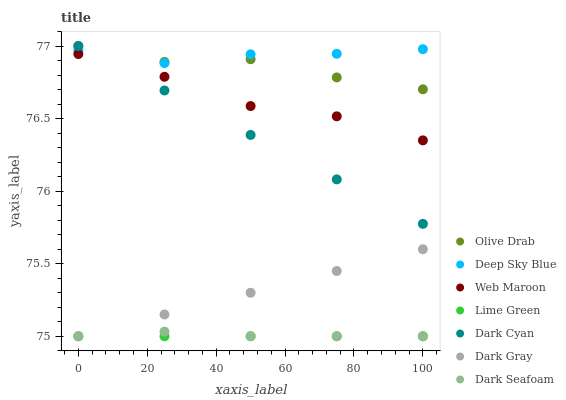Does Lime Green have the minimum area under the curve?
Answer yes or no. Yes. Does Deep Sky Blue have the maximum area under the curve?
Answer yes or no. Yes. Does Dark Gray have the minimum area under the curve?
Answer yes or no. No. Does Dark Gray have the maximum area under the curve?
Answer yes or no. No. Is Lime Green the smoothest?
Answer yes or no. Yes. Is Olive Drab the roughest?
Answer yes or no. Yes. Is Dark Gray the smoothest?
Answer yes or no. No. Is Dark Gray the roughest?
Answer yes or no. No. Does Dark Gray have the lowest value?
Answer yes or no. Yes. Does Deep Sky Blue have the lowest value?
Answer yes or no. No. Does Olive Drab have the highest value?
Answer yes or no. Yes. Does Dark Gray have the highest value?
Answer yes or no. No. Is Lime Green less than Web Maroon?
Answer yes or no. Yes. Is Olive Drab greater than Lime Green?
Answer yes or no. Yes. Does Olive Drab intersect Deep Sky Blue?
Answer yes or no. Yes. Is Olive Drab less than Deep Sky Blue?
Answer yes or no. No. Is Olive Drab greater than Deep Sky Blue?
Answer yes or no. No. Does Lime Green intersect Web Maroon?
Answer yes or no. No. 